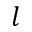<formula> <loc_0><loc_0><loc_500><loc_500>l</formula> 